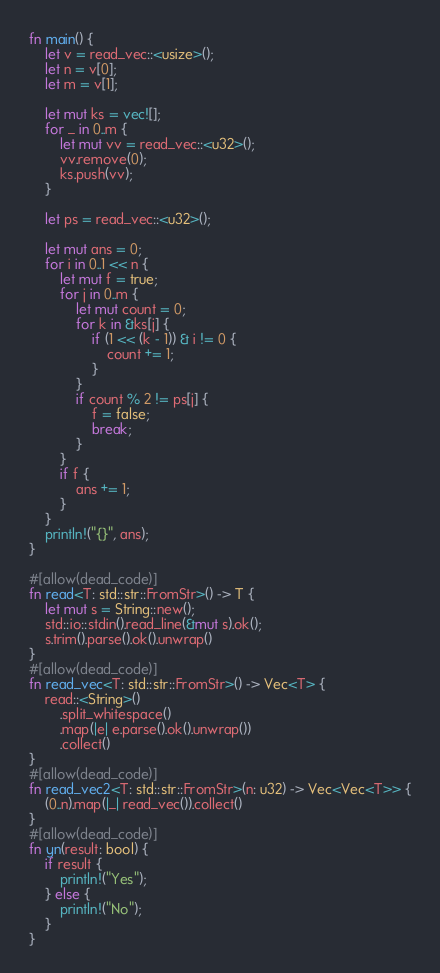<code> <loc_0><loc_0><loc_500><loc_500><_Rust_>fn main() {
    let v = read_vec::<usize>();
    let n = v[0];
    let m = v[1];

    let mut ks = vec![];
    for _ in 0..m {
        let mut vv = read_vec::<u32>();
        vv.remove(0);
        ks.push(vv);
    }

    let ps = read_vec::<u32>();

    let mut ans = 0;
    for i in 0..1 << n {
        let mut f = true;
        for j in 0..m {
            let mut count = 0;
            for k in &ks[j] {
                if (1 << (k - 1)) & i != 0 {
                    count += 1;
                }
            }
            if count % 2 != ps[j] {
                f = false;
                break;
            }
        }
        if f {
            ans += 1;
        }
    }
    println!("{}", ans);
}

#[allow(dead_code)]
fn read<T: std::str::FromStr>() -> T {
    let mut s = String::new();
    std::io::stdin().read_line(&mut s).ok();
    s.trim().parse().ok().unwrap()
}
#[allow(dead_code)]
fn read_vec<T: std::str::FromStr>() -> Vec<T> {
    read::<String>()
        .split_whitespace()
        .map(|e| e.parse().ok().unwrap())
        .collect()
}
#[allow(dead_code)]
fn read_vec2<T: std::str::FromStr>(n: u32) -> Vec<Vec<T>> {
    (0..n).map(|_| read_vec()).collect()
}
#[allow(dead_code)]
fn yn(result: bool) {
    if result {
        println!("Yes");
    } else {
        println!("No");
    }
}
</code> 